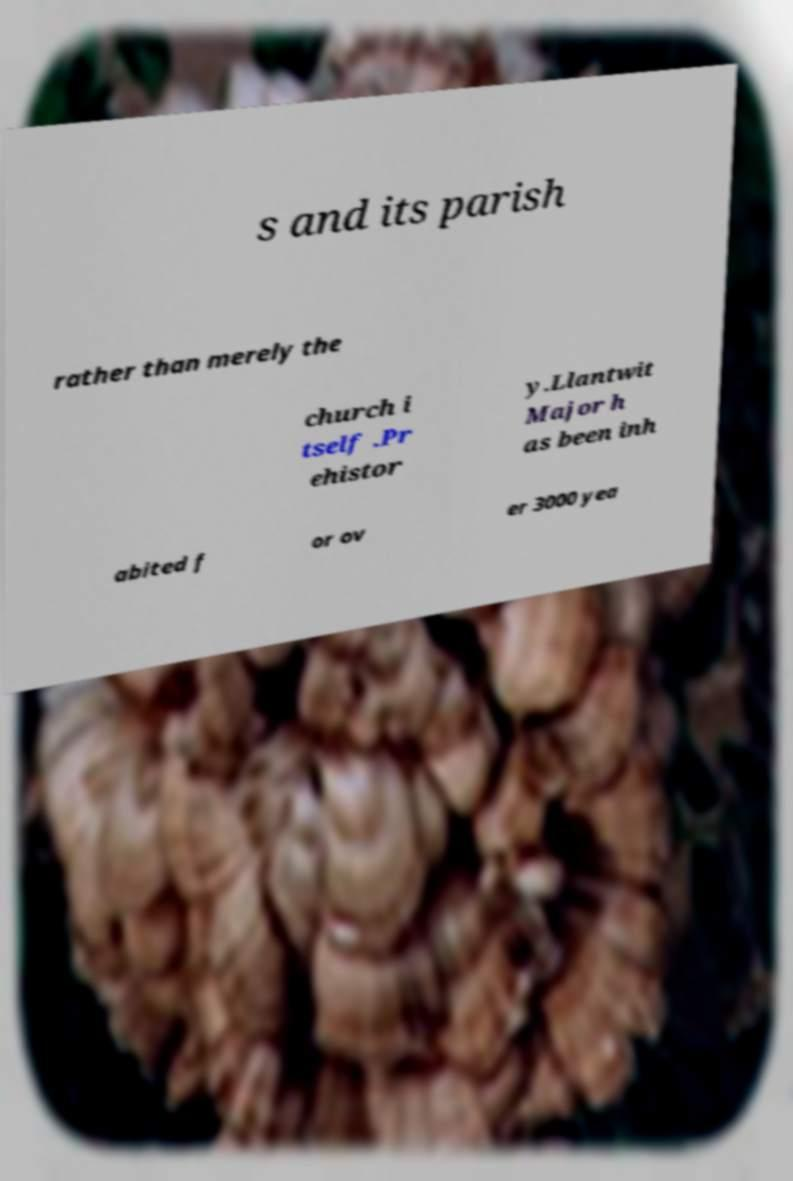For documentation purposes, I need the text within this image transcribed. Could you provide that? s and its parish rather than merely the church i tself .Pr ehistor y.Llantwit Major h as been inh abited f or ov er 3000 yea 